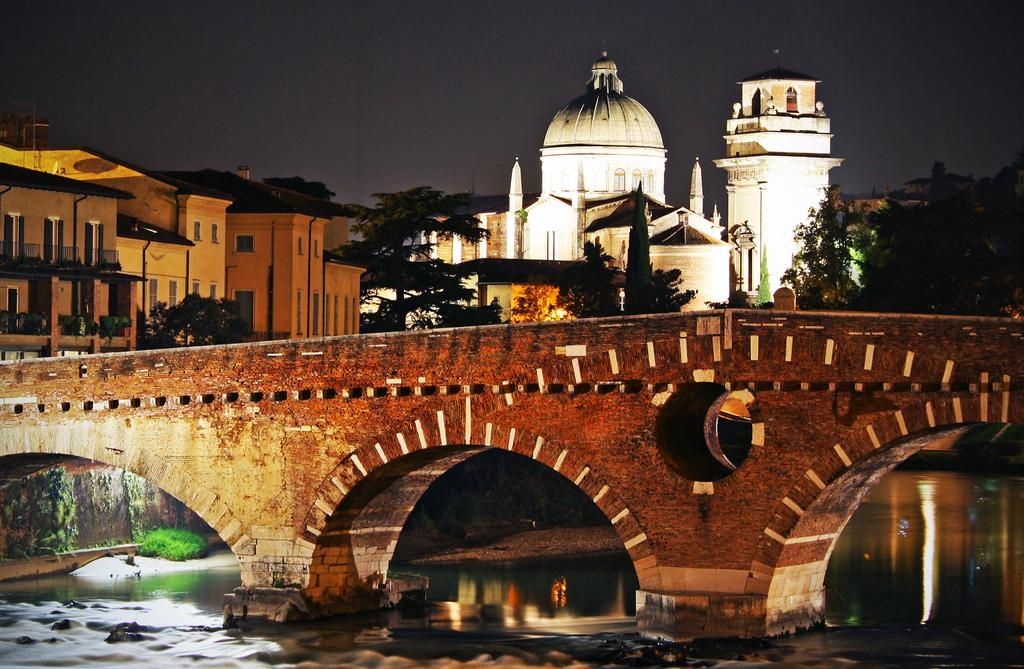What is the main structure in the center of the image? There is a bridge in the center of the image. What can be seen at the bottom of the image? There is water visible at the bottom of the image. What type of natural scenery is in the background of the image? There are trees in the background of the image. What type of man-made structures can be seen in the background of the image? There are buildings in the background of the image. What part of the natural environment is visible in the background of the image? The sky is visible in the background of the image. What type of machine is being used to cook the meat in the image? There is no machine or meat present in the image; it features a bridge, water, trees, buildings, and the sky. 